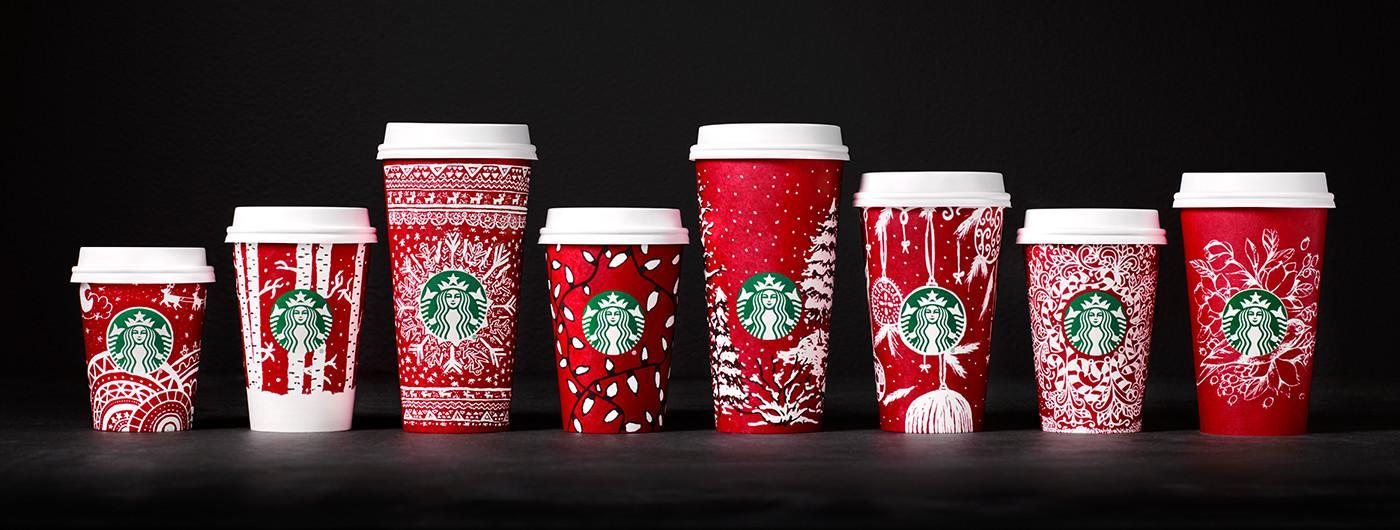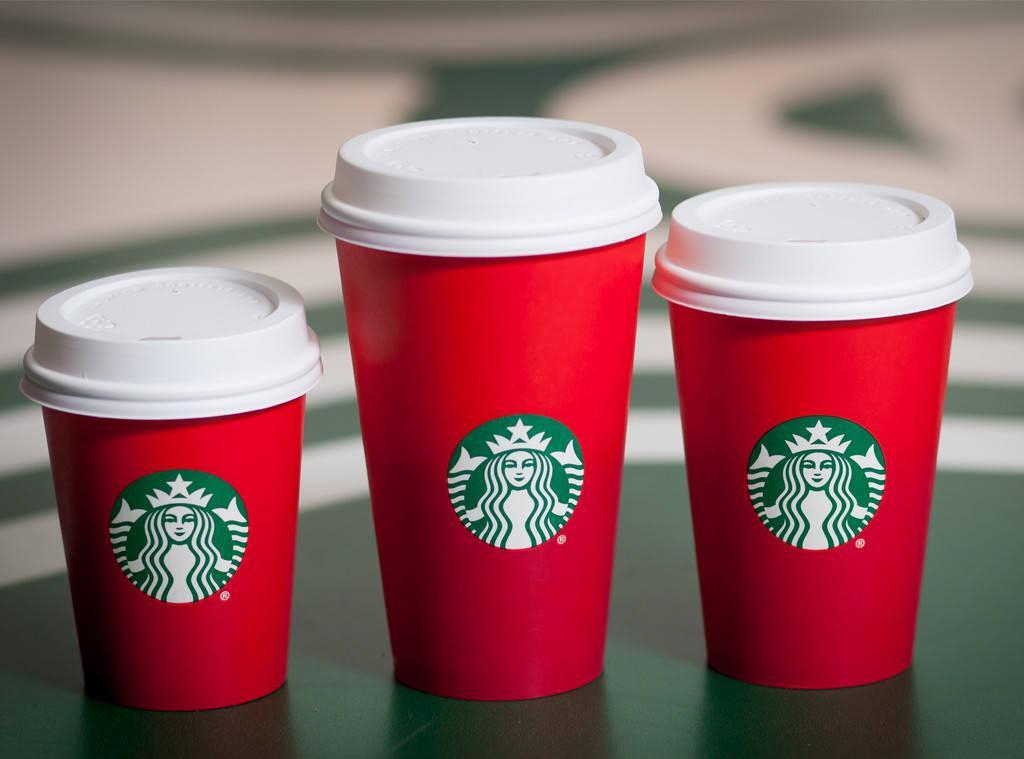The first image is the image on the left, the second image is the image on the right. Given the left and right images, does the statement "In at least one image there are seven red starbucks christmas cups full of coffee." hold true? Answer yes or no. No. 